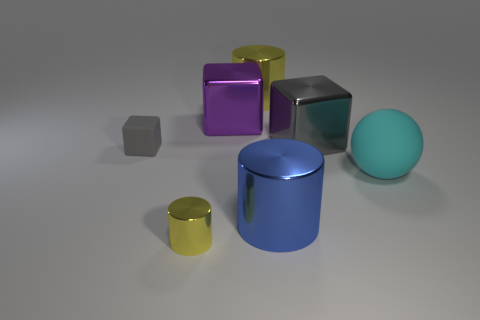How many yellow cylinders must be subtracted to get 1 yellow cylinders? 1 Add 1 big objects. How many objects exist? 8 Subtract all cubes. How many objects are left? 4 Subtract 0 green balls. How many objects are left? 7 Subtract all big cyan cylinders. Subtract all tiny metal objects. How many objects are left? 6 Add 6 large blue objects. How many large blue objects are left? 7 Add 2 large blue matte spheres. How many large blue matte spheres exist? 2 